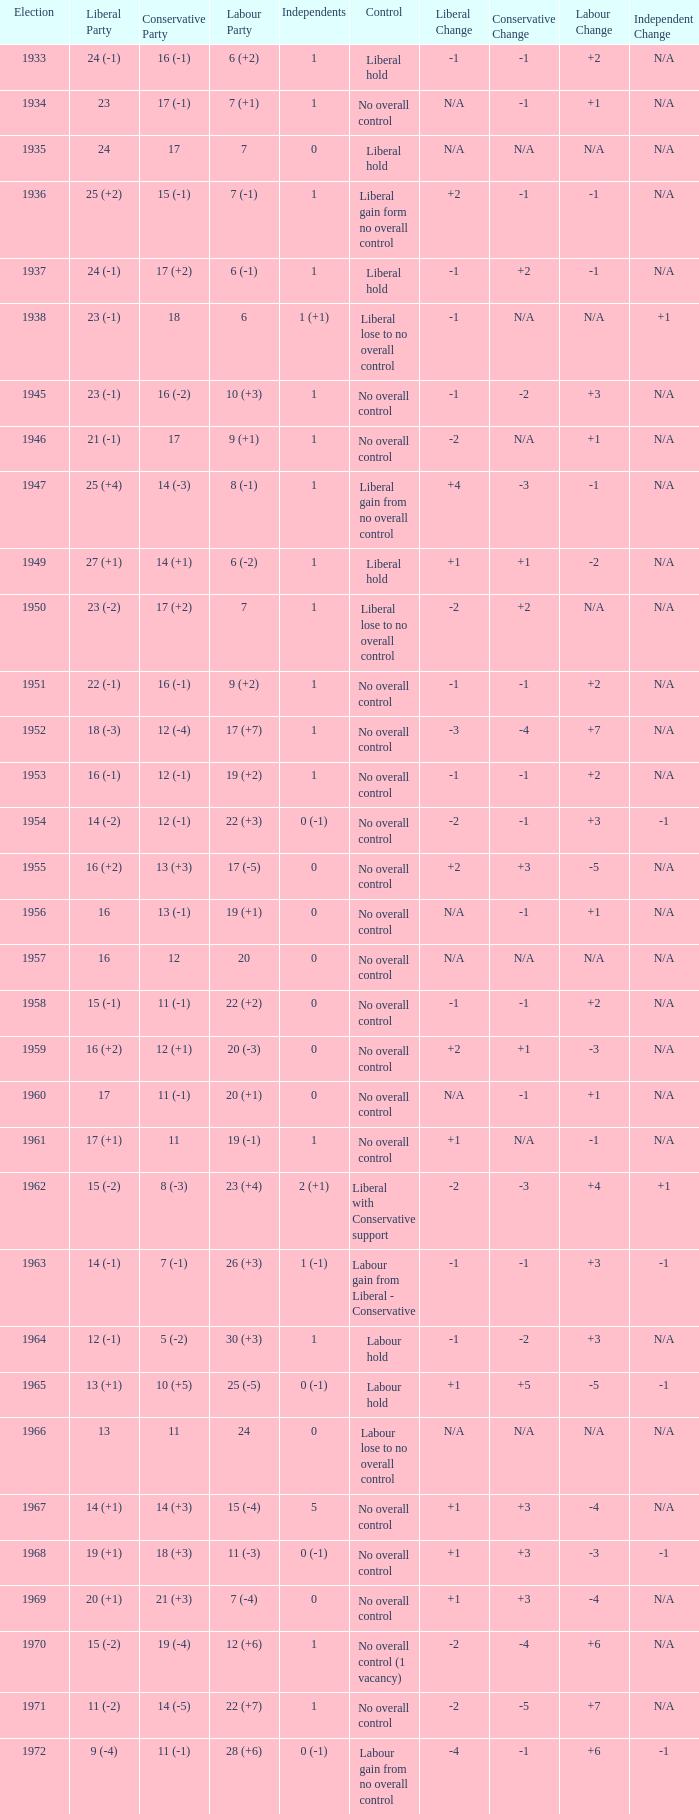What was the Liberal Party result from the election having a Conservative Party result of 16 (-1) and Labour of 6 (+2)? 24 (-1). 